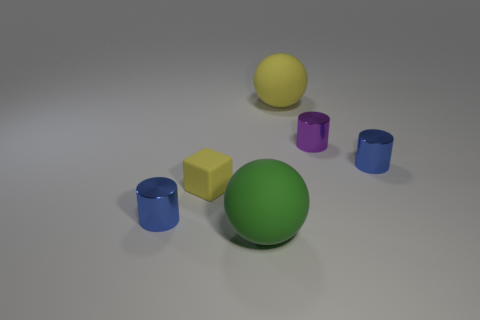What number of cylinders are blue shiny things or small yellow objects?
Offer a very short reply. 2. What is the size of the sphere that is behind the tiny blue shiny thing that is on the right side of the green sphere?
Offer a very short reply. Large. Does the small rubber block have the same color as the cylinder that is to the left of the large yellow matte ball?
Your response must be concise. No. There is a green sphere; what number of small shiny objects are on the right side of it?
Provide a succinct answer. 2. Is the number of gray metallic things less than the number of big green things?
Give a very brief answer. Yes. There is a thing that is to the right of the green thing and to the left of the purple metallic object; how big is it?
Give a very brief answer. Large. There is a shiny thing on the left side of the tiny cube; is its color the same as the tiny rubber block?
Your response must be concise. No. Is the number of tiny objects that are to the right of the large yellow sphere less than the number of large green matte balls?
Offer a very short reply. No. What is the shape of the other yellow object that is the same material as the big yellow thing?
Your answer should be very brief. Cube. Is the material of the green object the same as the tiny cube?
Offer a very short reply. Yes. 